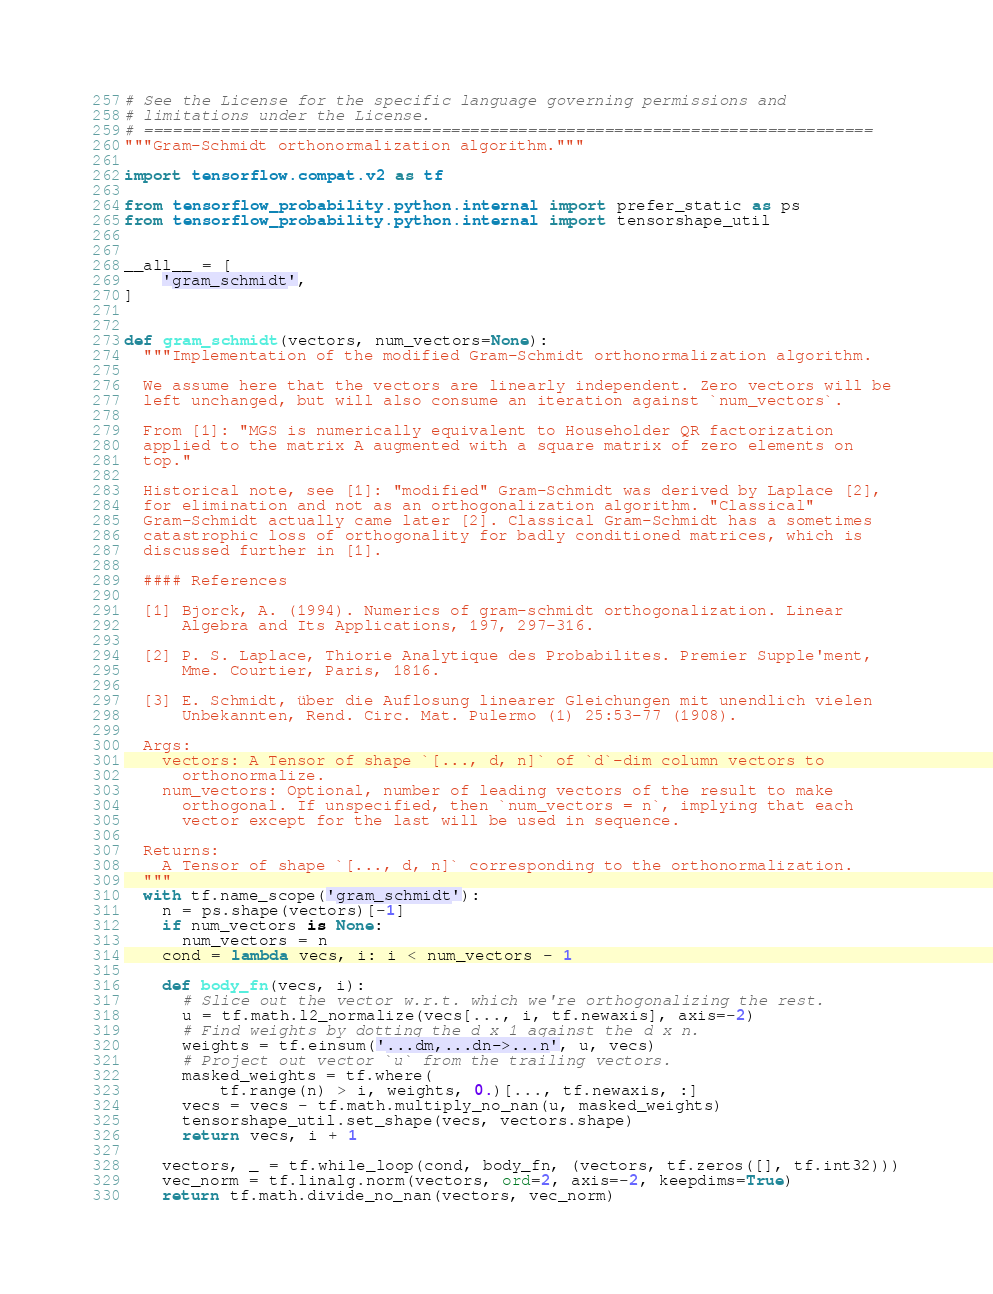<code> <loc_0><loc_0><loc_500><loc_500><_Python_># See the License for the specific language governing permissions and
# limitations under the License.
# ============================================================================
"""Gram-Schmidt orthonormalization algorithm."""

import tensorflow.compat.v2 as tf

from tensorflow_probability.python.internal import prefer_static as ps
from tensorflow_probability.python.internal import tensorshape_util


__all__ = [
    'gram_schmidt',
]


def gram_schmidt(vectors, num_vectors=None):
  """Implementation of the modified Gram-Schmidt orthonormalization algorithm.

  We assume here that the vectors are linearly independent. Zero vectors will be
  left unchanged, but will also consume an iteration against `num_vectors`.

  From [1]: "MGS is numerically equivalent to Householder QR factorization
  applied to the matrix A augmented with a square matrix of zero elements on
  top."

  Historical note, see [1]: "modified" Gram-Schmidt was derived by Laplace [2],
  for elimination and not as an orthogonalization algorithm. "Classical"
  Gram-Schmidt actually came later [2]. Classical Gram-Schmidt has a sometimes
  catastrophic loss of orthogonality for badly conditioned matrices, which is
  discussed further in [1].

  #### References

  [1] Bjorck, A. (1994). Numerics of gram-schmidt orthogonalization. Linear
      Algebra and Its Applications, 197, 297-316.

  [2] P. S. Laplace, Thiorie Analytique des Probabilites. Premier Supple'ment,
      Mme. Courtier, Paris, 1816.

  [3] E. Schmidt, über die Auflosung linearer Gleichungen mit unendlich vielen
      Unbekannten, Rend. Circ. Mat. Pulermo (1) 25:53-77 (1908).

  Args:
    vectors: A Tensor of shape `[..., d, n]` of `d`-dim column vectors to
      orthonormalize.
    num_vectors: Optional, number of leading vectors of the result to make
      orthogonal. If unspecified, then `num_vectors = n`, implying that each
      vector except for the last will be used in sequence.

  Returns:
    A Tensor of shape `[..., d, n]` corresponding to the orthonormalization.
  """
  with tf.name_scope('gram_schmidt'):
    n = ps.shape(vectors)[-1]
    if num_vectors is None:
      num_vectors = n
    cond = lambda vecs, i: i < num_vectors - 1

    def body_fn(vecs, i):
      # Slice out the vector w.r.t. which we're orthogonalizing the rest.
      u = tf.math.l2_normalize(vecs[..., i, tf.newaxis], axis=-2)
      # Find weights by dotting the d x 1 against the d x n.
      weights = tf.einsum('...dm,...dn->...n', u, vecs)
      # Project out vector `u` from the trailing vectors.
      masked_weights = tf.where(
          tf.range(n) > i, weights, 0.)[..., tf.newaxis, :]
      vecs = vecs - tf.math.multiply_no_nan(u, masked_weights)
      tensorshape_util.set_shape(vecs, vectors.shape)
      return vecs, i + 1

    vectors, _ = tf.while_loop(cond, body_fn, (vectors, tf.zeros([], tf.int32)))
    vec_norm = tf.linalg.norm(vectors, ord=2, axis=-2, keepdims=True)
    return tf.math.divide_no_nan(vectors, vec_norm)
</code> 